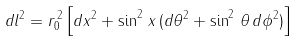Convert formula to latex. <formula><loc_0><loc_0><loc_500><loc_500>d l ^ { 2 } = r _ { 0 } ^ { \, 2 } \left [ d x ^ { 2 } + \sin ^ { 2 } \, x \, ( d \theta ^ { 2 } + \sin ^ { 2 } \, \theta \, d \phi ^ { 2 } ) \right ]</formula> 